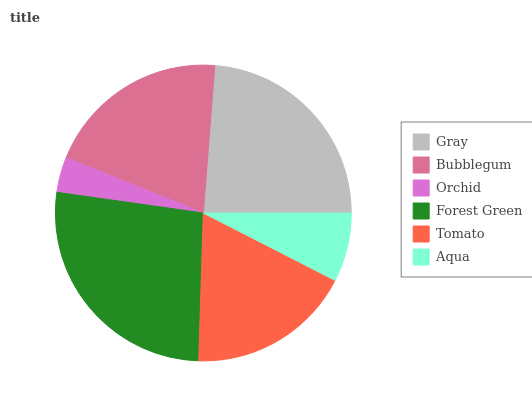Is Orchid the minimum?
Answer yes or no. Yes. Is Forest Green the maximum?
Answer yes or no. Yes. Is Bubblegum the minimum?
Answer yes or no. No. Is Bubblegum the maximum?
Answer yes or no. No. Is Gray greater than Bubblegum?
Answer yes or no. Yes. Is Bubblegum less than Gray?
Answer yes or no. Yes. Is Bubblegum greater than Gray?
Answer yes or no. No. Is Gray less than Bubblegum?
Answer yes or no. No. Is Bubblegum the high median?
Answer yes or no. Yes. Is Tomato the low median?
Answer yes or no. Yes. Is Gray the high median?
Answer yes or no. No. Is Bubblegum the low median?
Answer yes or no. No. 